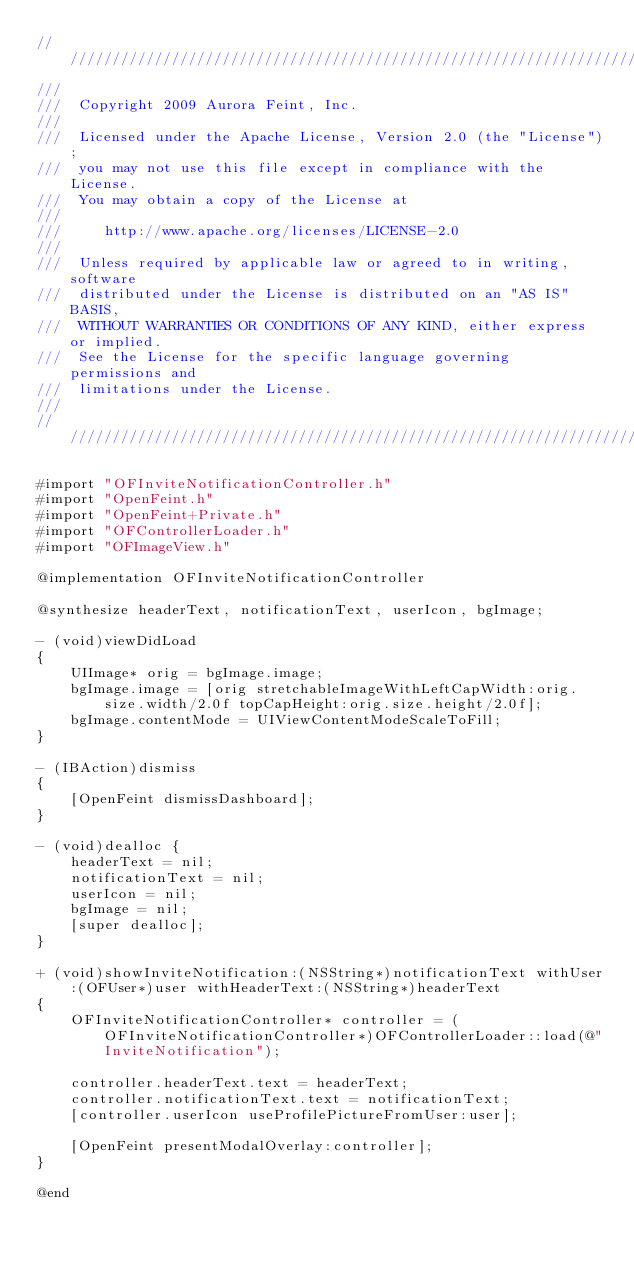<code> <loc_0><loc_0><loc_500><loc_500><_ObjectiveC_>////////////////////////////////////////////////////////////////////////////////////////////////////////////////////////
/// 
///  Copyright 2009 Aurora Feint, Inc.
/// 
///  Licensed under the Apache License, Version 2.0 (the "License");
///  you may not use this file except in compliance with the License.
///  You may obtain a copy of the License at
///  
///  	http://www.apache.org/licenses/LICENSE-2.0
///  	
///  Unless required by applicable law or agreed to in writing, software
///  distributed under the License is distributed on an "AS IS" BASIS,
///  WITHOUT WARRANTIES OR CONDITIONS OF ANY KIND, either express or implied.
///  See the License for the specific language governing permissions and
///  limitations under the License.
/// 
////////////////////////////////////////////////////////////////////////////////////////////////////////////////////////

#import "OFInviteNotificationController.h"
#import "OpenFeint.h"
#import "OpenFeint+Private.h"
#import "OFControllerLoader.h"
#import "OFImageView.h"

@implementation OFInviteNotificationController

@synthesize headerText, notificationText, userIcon, bgImage;

- (void)viewDidLoad
{
	UIImage* orig = bgImage.image;
	bgImage.image = [orig stretchableImageWithLeftCapWidth:orig.size.width/2.0f topCapHeight:orig.size.height/2.0f];
	bgImage.contentMode = UIViewContentModeScaleToFill;
}

- (IBAction)dismiss
{
	[OpenFeint dismissDashboard];
}

- (void)dealloc {
	headerText = nil;
	notificationText = nil;
	userIcon = nil;
	bgImage = nil;
    [super dealloc];
}

+ (void)showInviteNotification:(NSString*)notificationText withUser:(OFUser*)user withHeaderText:(NSString*)headerText
{
	OFInviteNotificationController* controller = (OFInviteNotificationController*)OFControllerLoader::load(@"InviteNotification");
	
	controller.headerText.text = headerText;
	controller.notificationText.text = notificationText;
	[controller.userIcon useProfilePictureFromUser:user];
	
	[OpenFeint presentModalOverlay:controller];
}

@end
</code> 